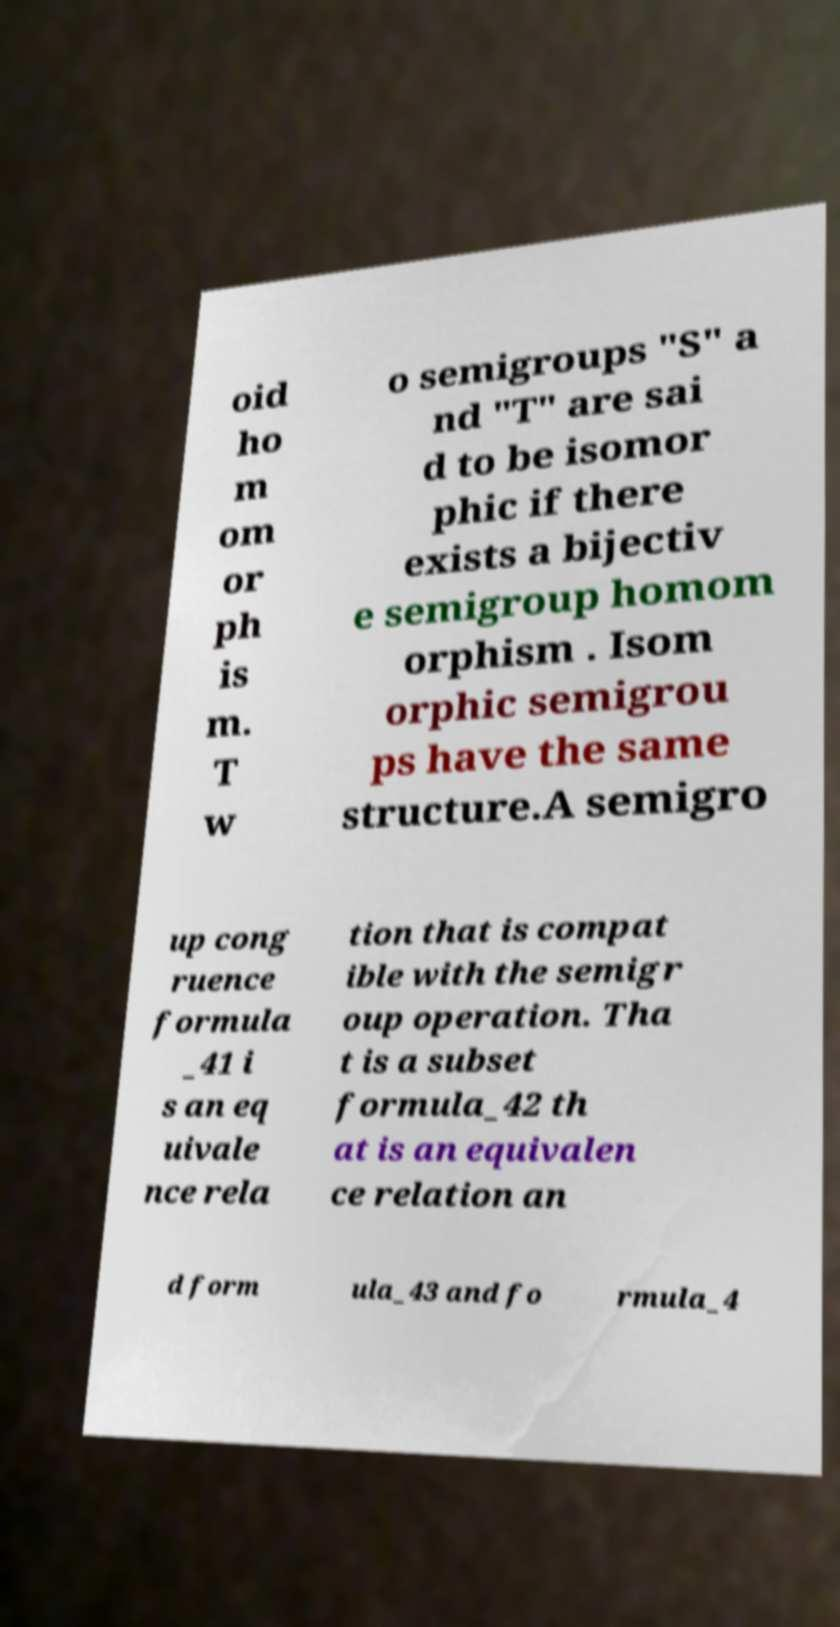What messages or text are displayed in this image? I need them in a readable, typed format. oid ho m om or ph is m. T w o semigroups "S" a nd "T" are sai d to be isomor phic if there exists a bijectiv e semigroup homom orphism . Isom orphic semigrou ps have the same structure.A semigro up cong ruence formula _41 i s an eq uivale nce rela tion that is compat ible with the semigr oup operation. Tha t is a subset formula_42 th at is an equivalen ce relation an d form ula_43 and fo rmula_4 